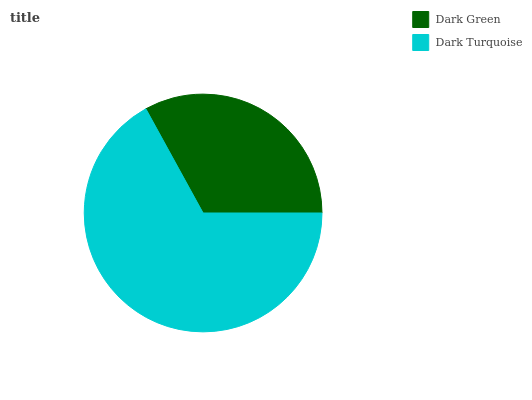Is Dark Green the minimum?
Answer yes or no. Yes. Is Dark Turquoise the maximum?
Answer yes or no. Yes. Is Dark Turquoise the minimum?
Answer yes or no. No. Is Dark Turquoise greater than Dark Green?
Answer yes or no. Yes. Is Dark Green less than Dark Turquoise?
Answer yes or no. Yes. Is Dark Green greater than Dark Turquoise?
Answer yes or no. No. Is Dark Turquoise less than Dark Green?
Answer yes or no. No. Is Dark Turquoise the high median?
Answer yes or no. Yes. Is Dark Green the low median?
Answer yes or no. Yes. Is Dark Green the high median?
Answer yes or no. No. Is Dark Turquoise the low median?
Answer yes or no. No. 